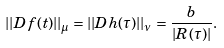Convert formula to latex. <formula><loc_0><loc_0><loc_500><loc_500>| | D f ( t ) | | _ { \mu } = | | D h ( \tau ) | | _ { \nu } = \frac { b } { | R ( \tau ) | } .</formula> 